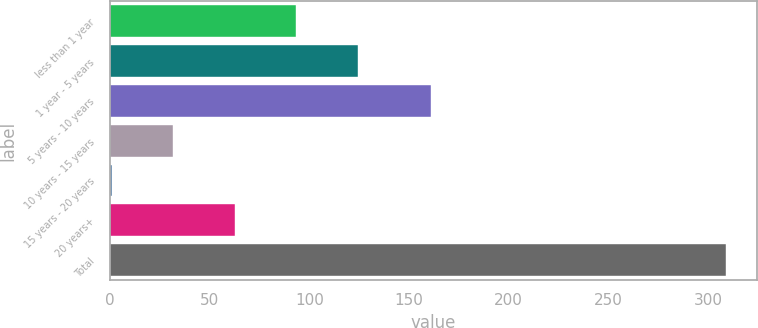<chart> <loc_0><loc_0><loc_500><loc_500><bar_chart><fcel>less than 1 year<fcel>1 year - 5 years<fcel>5 years - 10 years<fcel>10 years - 15 years<fcel>15 years - 20 years<fcel>20 years+<fcel>Total<nl><fcel>93.49<fcel>124.32<fcel>161.2<fcel>31.83<fcel>1<fcel>62.66<fcel>309.3<nl></chart> 